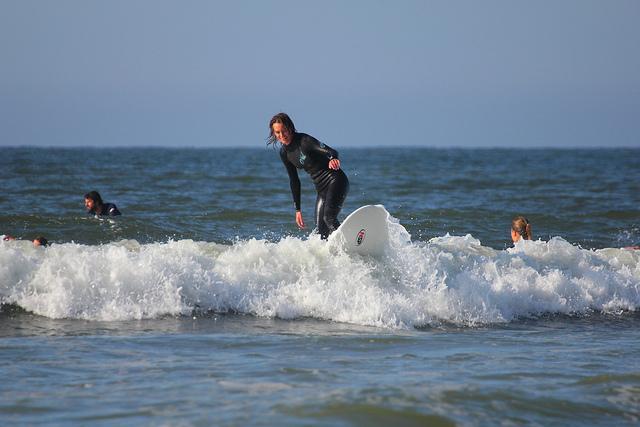What is the primary stripe color of the surfboard?
Keep it brief. White. How many persons are there?
Concise answer only. 4. What color is her wetsuit?
Short answer required. Black. How many people are shown?
Answer briefly. 4. Is the girl doing well at surfing?
Quick response, please. Yes. Is the main surfer 'riding a wave'?
Be succinct. Yes. How many People are there?
Quick response, please. 4. 